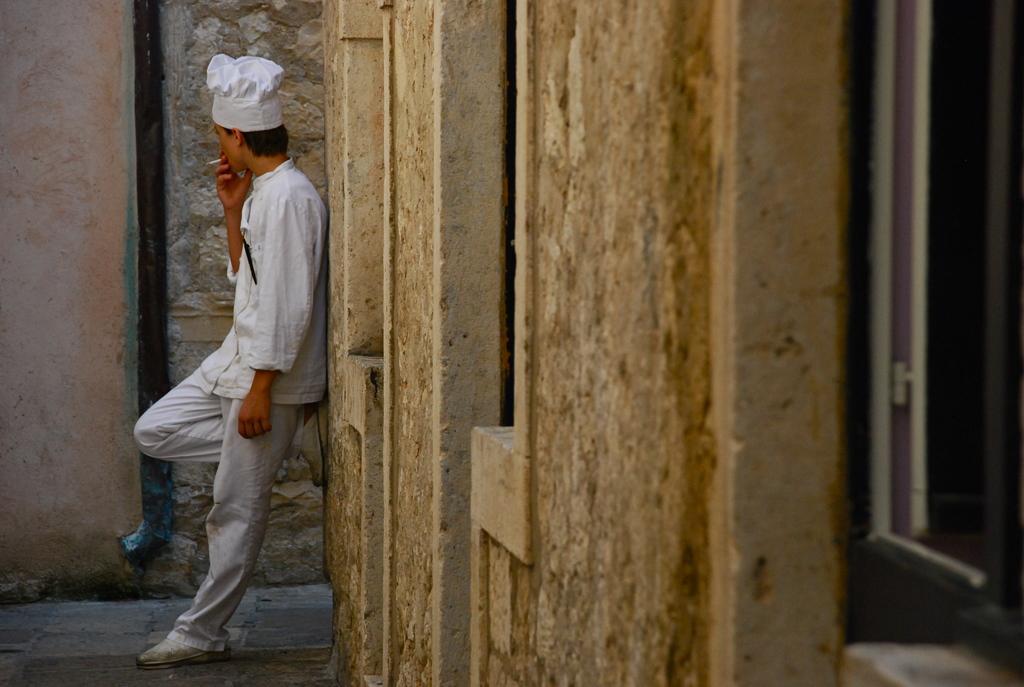Describe this image in one or two sentences. There is a person standing and smoking and wore cap. We can see walls and window. 